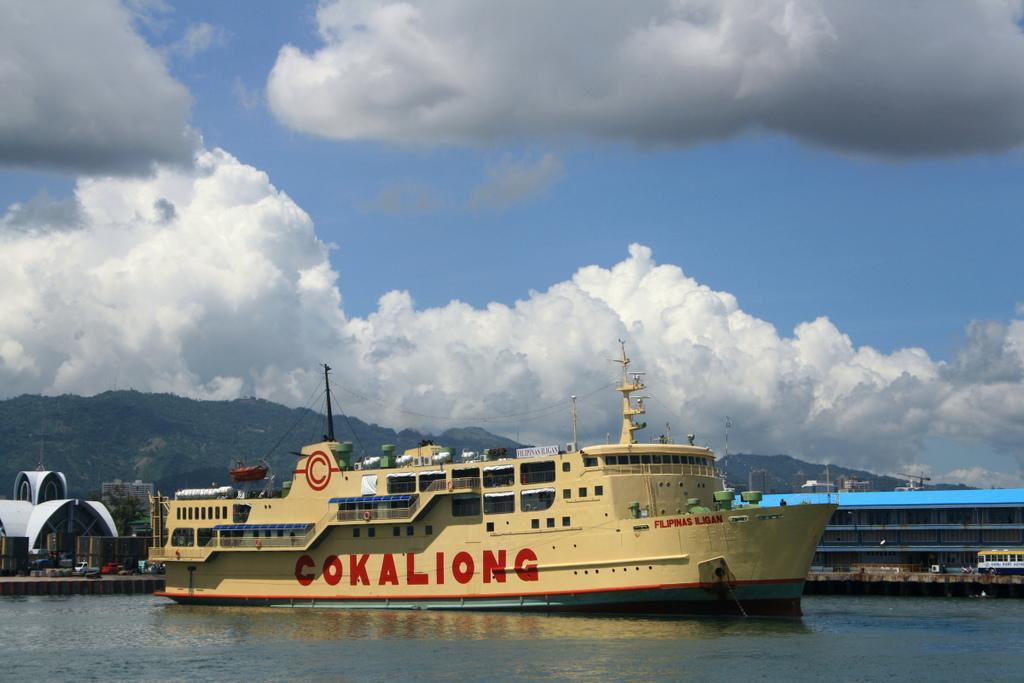Describe this image in one or two sentences. In this picture I can see there is a ship sailing in the water and in the backdrop there are buildings and there are some vehicles moving on the road. In the backdrop there are mountains and they are covered with trees and the sky is clear. 